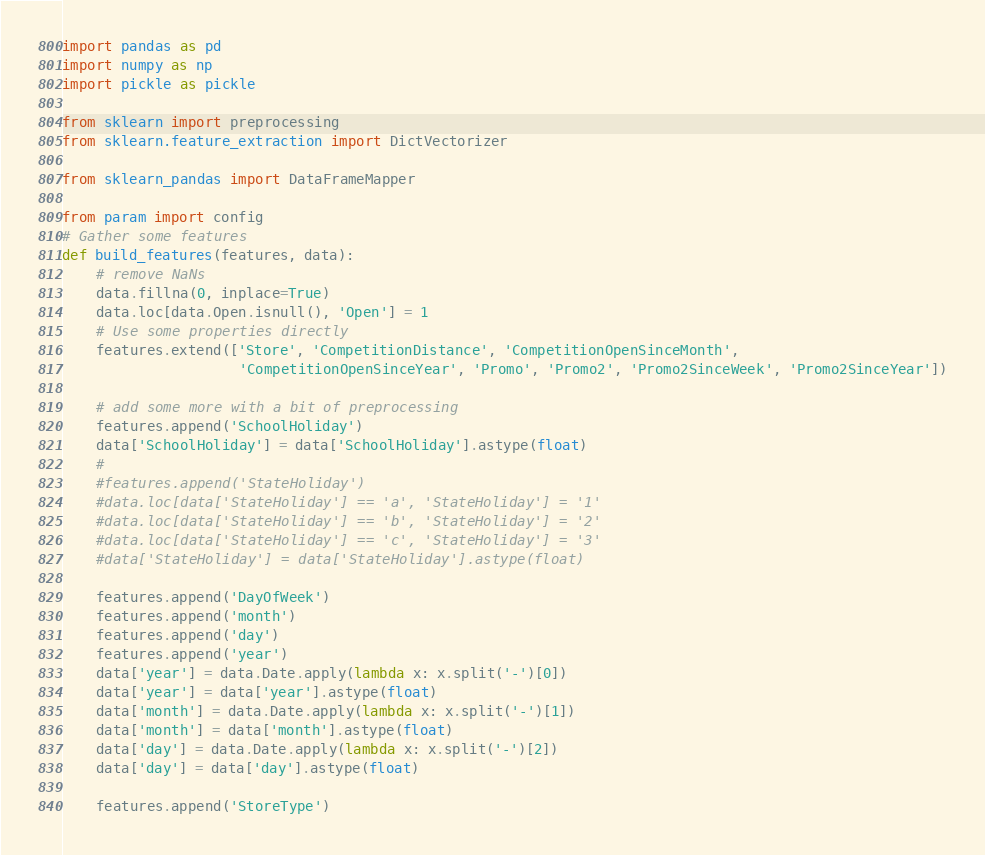Convert code to text. <code><loc_0><loc_0><loc_500><loc_500><_Python_>import pandas as pd
import numpy as np
import pickle as pickle

from sklearn import preprocessing
from sklearn.feature_extraction import DictVectorizer

from sklearn_pandas import DataFrameMapper

from param import config
# Gather some features
def build_features(features, data):
    # remove NaNs
    data.fillna(0, inplace=True)
    data.loc[data.Open.isnull(), 'Open'] = 1
    # Use some properties directly
    features.extend(['Store', 'CompetitionDistance', 'CompetitionOpenSinceMonth',
                     'CompetitionOpenSinceYear', 'Promo', 'Promo2', 'Promo2SinceWeek', 'Promo2SinceYear'])

    # add some more with a bit of preprocessing
    features.append('SchoolHoliday')
    data['SchoolHoliday'] = data['SchoolHoliday'].astype(float)
    #
    #features.append('StateHoliday')
    #data.loc[data['StateHoliday'] == 'a', 'StateHoliday'] = '1'
    #data.loc[data['StateHoliday'] == 'b', 'StateHoliday'] = '2'
    #data.loc[data['StateHoliday'] == 'c', 'StateHoliday'] = '3'
    #data['StateHoliday'] = data['StateHoliday'].astype(float)

    features.append('DayOfWeek')
    features.append('month')
    features.append('day')
    features.append('year')
    data['year'] = data.Date.apply(lambda x: x.split('-')[0])
    data['year'] = data['year'].astype(float)
    data['month'] = data.Date.apply(lambda x: x.split('-')[1])
    data['month'] = data['month'].astype(float)
    data['day'] = data.Date.apply(lambda x: x.split('-')[2])
    data['day'] = data['day'].astype(float)

    features.append('StoreType')</code> 